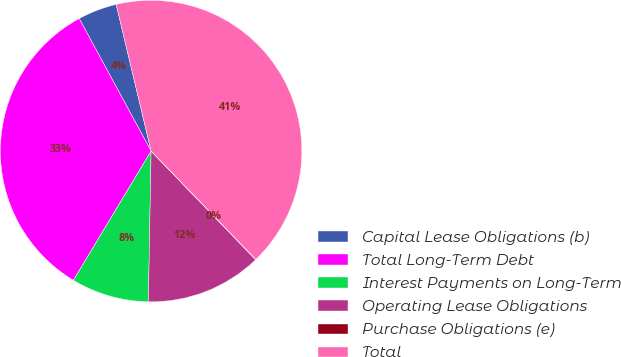<chart> <loc_0><loc_0><loc_500><loc_500><pie_chart><fcel>Capital Lease Obligations (b)<fcel>Total Long-Term Debt<fcel>Interest Payments on Long-Term<fcel>Operating Lease Obligations<fcel>Purchase Obligations (e)<fcel>Total<nl><fcel>4.19%<fcel>33.47%<fcel>8.33%<fcel>12.48%<fcel>0.04%<fcel>41.49%<nl></chart> 